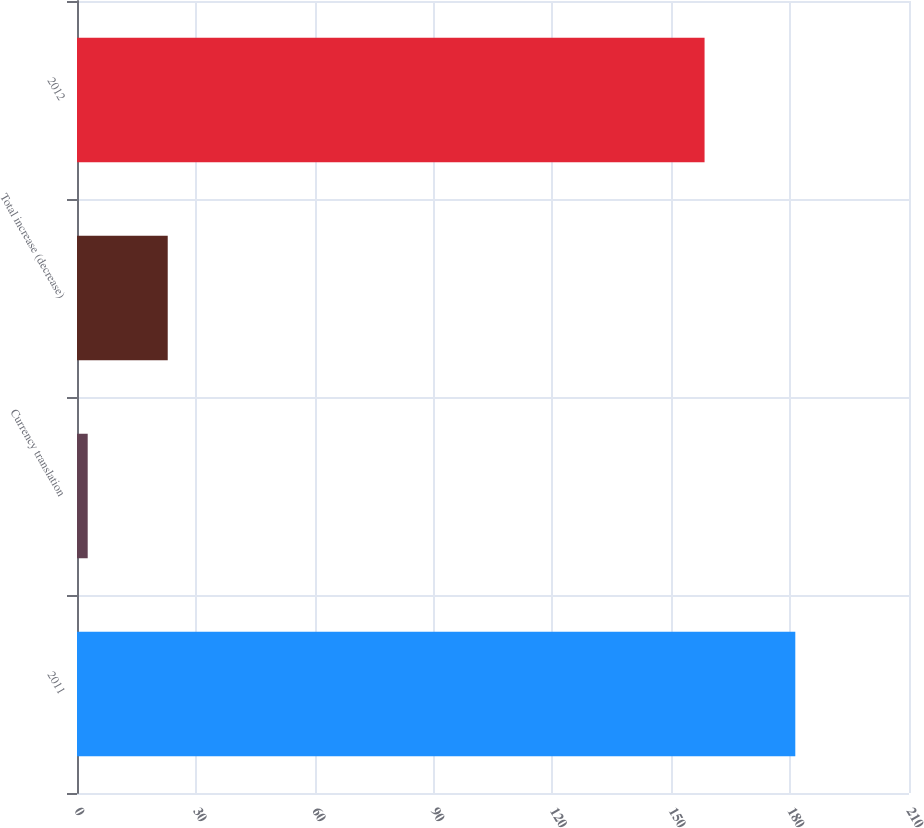Convert chart. <chart><loc_0><loc_0><loc_500><loc_500><bar_chart><fcel>2011<fcel>Currency translation<fcel>Total increase (decrease)<fcel>2012<nl><fcel>181.3<fcel>2.7<fcel>22.9<fcel>158.4<nl></chart> 